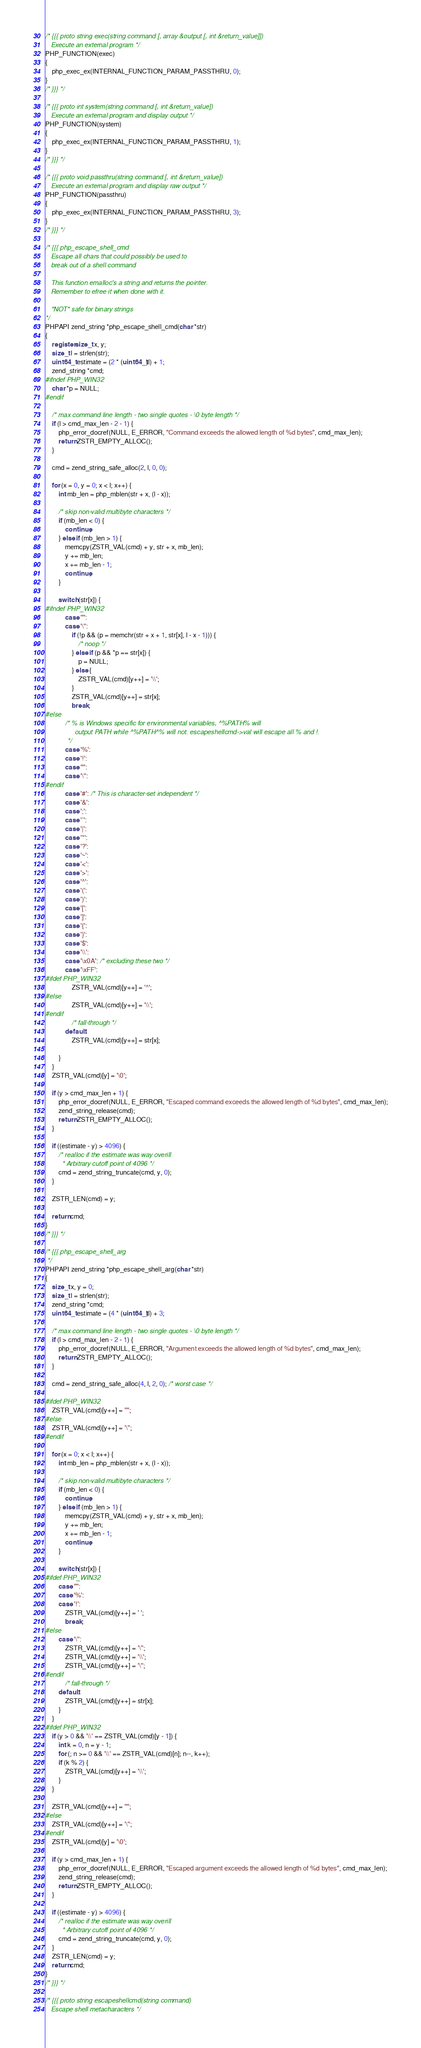<code> <loc_0><loc_0><loc_500><loc_500><_C_>/* {{{ proto string exec(string command [, array &output [, int &return_value]])
   Execute an external program */
PHP_FUNCTION(exec)
{
	php_exec_ex(INTERNAL_FUNCTION_PARAM_PASSTHRU, 0);
}
/* }}} */

/* {{{ proto int system(string command [, int &return_value])
   Execute an external program and display output */
PHP_FUNCTION(system)
{
	php_exec_ex(INTERNAL_FUNCTION_PARAM_PASSTHRU, 1);
}
/* }}} */

/* {{{ proto void passthru(string command [, int &return_value])
   Execute an external program and display raw output */
PHP_FUNCTION(passthru)
{
	php_exec_ex(INTERNAL_FUNCTION_PARAM_PASSTHRU, 3);
}
/* }}} */

/* {{{ php_escape_shell_cmd
   Escape all chars that could possibly be used to
   break out of a shell command

   This function emalloc's a string and returns the pointer.
   Remember to efree it when done with it.

   *NOT* safe for binary strings
*/
PHPAPI zend_string *php_escape_shell_cmd(char *str)
{
	register size_t x, y;
	size_t l = strlen(str);
	uint64_t estimate = (2 * (uint64_t)l) + 1;
	zend_string *cmd;
#ifndef PHP_WIN32
	char *p = NULL;
#endif

	/* max command line length - two single quotes - \0 byte length */
	if (l > cmd_max_len - 2 - 1) {
		php_error_docref(NULL, E_ERROR, "Command exceeds the allowed length of %d bytes", cmd_max_len);
		return ZSTR_EMPTY_ALLOC();
	}

	cmd = zend_string_safe_alloc(2, l, 0, 0);

	for (x = 0, y = 0; x < l; x++) {
		int mb_len = php_mblen(str + x, (l - x));

		/* skip non-valid multibyte characters */
		if (mb_len < 0) {
			continue;
		} else if (mb_len > 1) {
			memcpy(ZSTR_VAL(cmd) + y, str + x, mb_len);
			y += mb_len;
			x += mb_len - 1;
			continue;
		}

		switch (str[x]) {
#ifndef PHP_WIN32
			case '"':
			case '\'':
				if (!p && (p = memchr(str + x + 1, str[x], l - x - 1))) {
					/* noop */
				} else if (p && *p == str[x]) {
					p = NULL;
				} else {
					ZSTR_VAL(cmd)[y++] = '\\';
				}
				ZSTR_VAL(cmd)[y++] = str[x];
				break;
#else
			/* % is Windows specific for environmental variables, ^%PATH% will
				output PATH while ^%PATH^% will not. escapeshellcmd->val will escape all % and !.
			*/
			case '%':
			case '!':
			case '"':
			case '\'':
#endif
			case '#': /* This is character-set independent */
			case '&':
			case ';':
			case '`':
			case '|':
			case '*':
			case '?':
			case '~':
			case '<':
			case '>':
			case '^':
			case '(':
			case ')':
			case '[':
			case ']':
			case '{':
			case '}':
			case '$':
			case '\\':
			case '\x0A': /* excluding these two */
			case '\xFF':
#ifdef PHP_WIN32
				ZSTR_VAL(cmd)[y++] = '^';
#else
				ZSTR_VAL(cmd)[y++] = '\\';
#endif
				/* fall-through */
			default:
				ZSTR_VAL(cmd)[y++] = str[x];

		}
	}
	ZSTR_VAL(cmd)[y] = '\0';

	if (y > cmd_max_len + 1) {
		php_error_docref(NULL, E_ERROR, "Escaped command exceeds the allowed length of %d bytes", cmd_max_len);
		zend_string_release(cmd);
		return ZSTR_EMPTY_ALLOC();
	}

	if ((estimate - y) > 4096) {
		/* realloc if the estimate was way overill
		 * Arbitrary cutoff point of 4096 */
		cmd = zend_string_truncate(cmd, y, 0);
	}

	ZSTR_LEN(cmd) = y;

	return cmd;
}
/* }}} */

/* {{{ php_escape_shell_arg
 */
PHPAPI zend_string *php_escape_shell_arg(char *str)
{
	size_t x, y = 0;
	size_t l = strlen(str);
	zend_string *cmd;
	uint64_t estimate = (4 * (uint64_t)l) + 3;

	/* max command line length - two single quotes - \0 byte length */
	if (l > cmd_max_len - 2 - 1) {
		php_error_docref(NULL, E_ERROR, "Argument exceeds the allowed length of %d bytes", cmd_max_len);
		return ZSTR_EMPTY_ALLOC();
	}

	cmd = zend_string_safe_alloc(4, l, 2, 0); /* worst case */

#ifdef PHP_WIN32
	ZSTR_VAL(cmd)[y++] = '"';
#else
	ZSTR_VAL(cmd)[y++] = '\'';
#endif

	for (x = 0; x < l; x++) {
		int mb_len = php_mblen(str + x, (l - x));

		/* skip non-valid multibyte characters */
		if (mb_len < 0) {
			continue;
		} else if (mb_len > 1) {
			memcpy(ZSTR_VAL(cmd) + y, str + x, mb_len);
			y += mb_len;
			x += mb_len - 1;
			continue;
		}

		switch (str[x]) {
#ifdef PHP_WIN32
		case '"':
		case '%':
		case '!':
			ZSTR_VAL(cmd)[y++] = ' ';
			break;
#else
		case '\'':
			ZSTR_VAL(cmd)[y++] = '\'';
			ZSTR_VAL(cmd)[y++] = '\\';
			ZSTR_VAL(cmd)[y++] = '\'';
#endif
			/* fall-through */
		default:
			ZSTR_VAL(cmd)[y++] = str[x];
		}
	}
#ifdef PHP_WIN32
	if (y > 0 && '\\' == ZSTR_VAL(cmd)[y - 1]) {
		int k = 0, n = y - 1;
		for (; n >= 0 && '\\' == ZSTR_VAL(cmd)[n]; n--, k++);
		if (k % 2) {
			ZSTR_VAL(cmd)[y++] = '\\';
		}
	}

	ZSTR_VAL(cmd)[y++] = '"';
#else
	ZSTR_VAL(cmd)[y++] = '\'';
#endif
	ZSTR_VAL(cmd)[y] = '\0';

	if (y > cmd_max_len + 1) {
		php_error_docref(NULL, E_ERROR, "Escaped argument exceeds the allowed length of %d bytes", cmd_max_len);
		zend_string_release(cmd);
		return ZSTR_EMPTY_ALLOC();
	}

	if ((estimate - y) > 4096) {
		/* realloc if the estimate was way overill
		 * Arbitrary cutoff point of 4096 */
		cmd = zend_string_truncate(cmd, y, 0);
	}
	ZSTR_LEN(cmd) = y;
	return cmd;
}
/* }}} */

/* {{{ proto string escapeshellcmd(string command)
   Escape shell metacharacters */</code> 